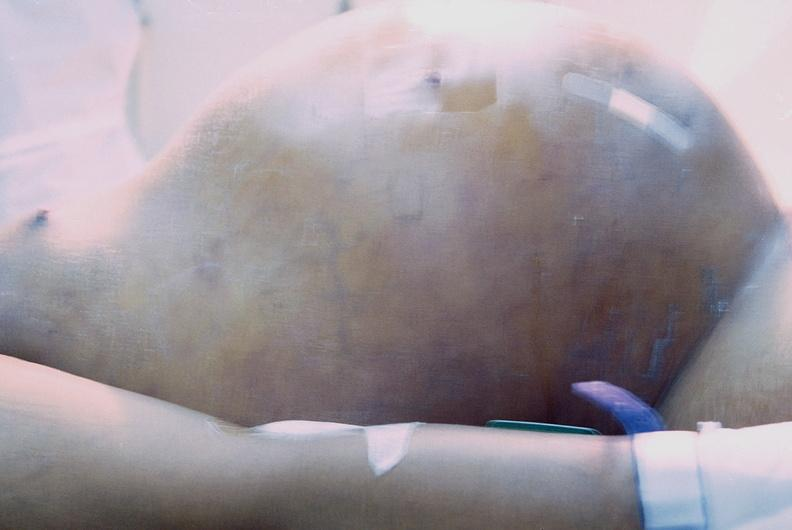s slices of liver and spleen typical tuberculous exudate is present on capsule of liver and spleen present?
Answer the question using a single word or phrase. No 